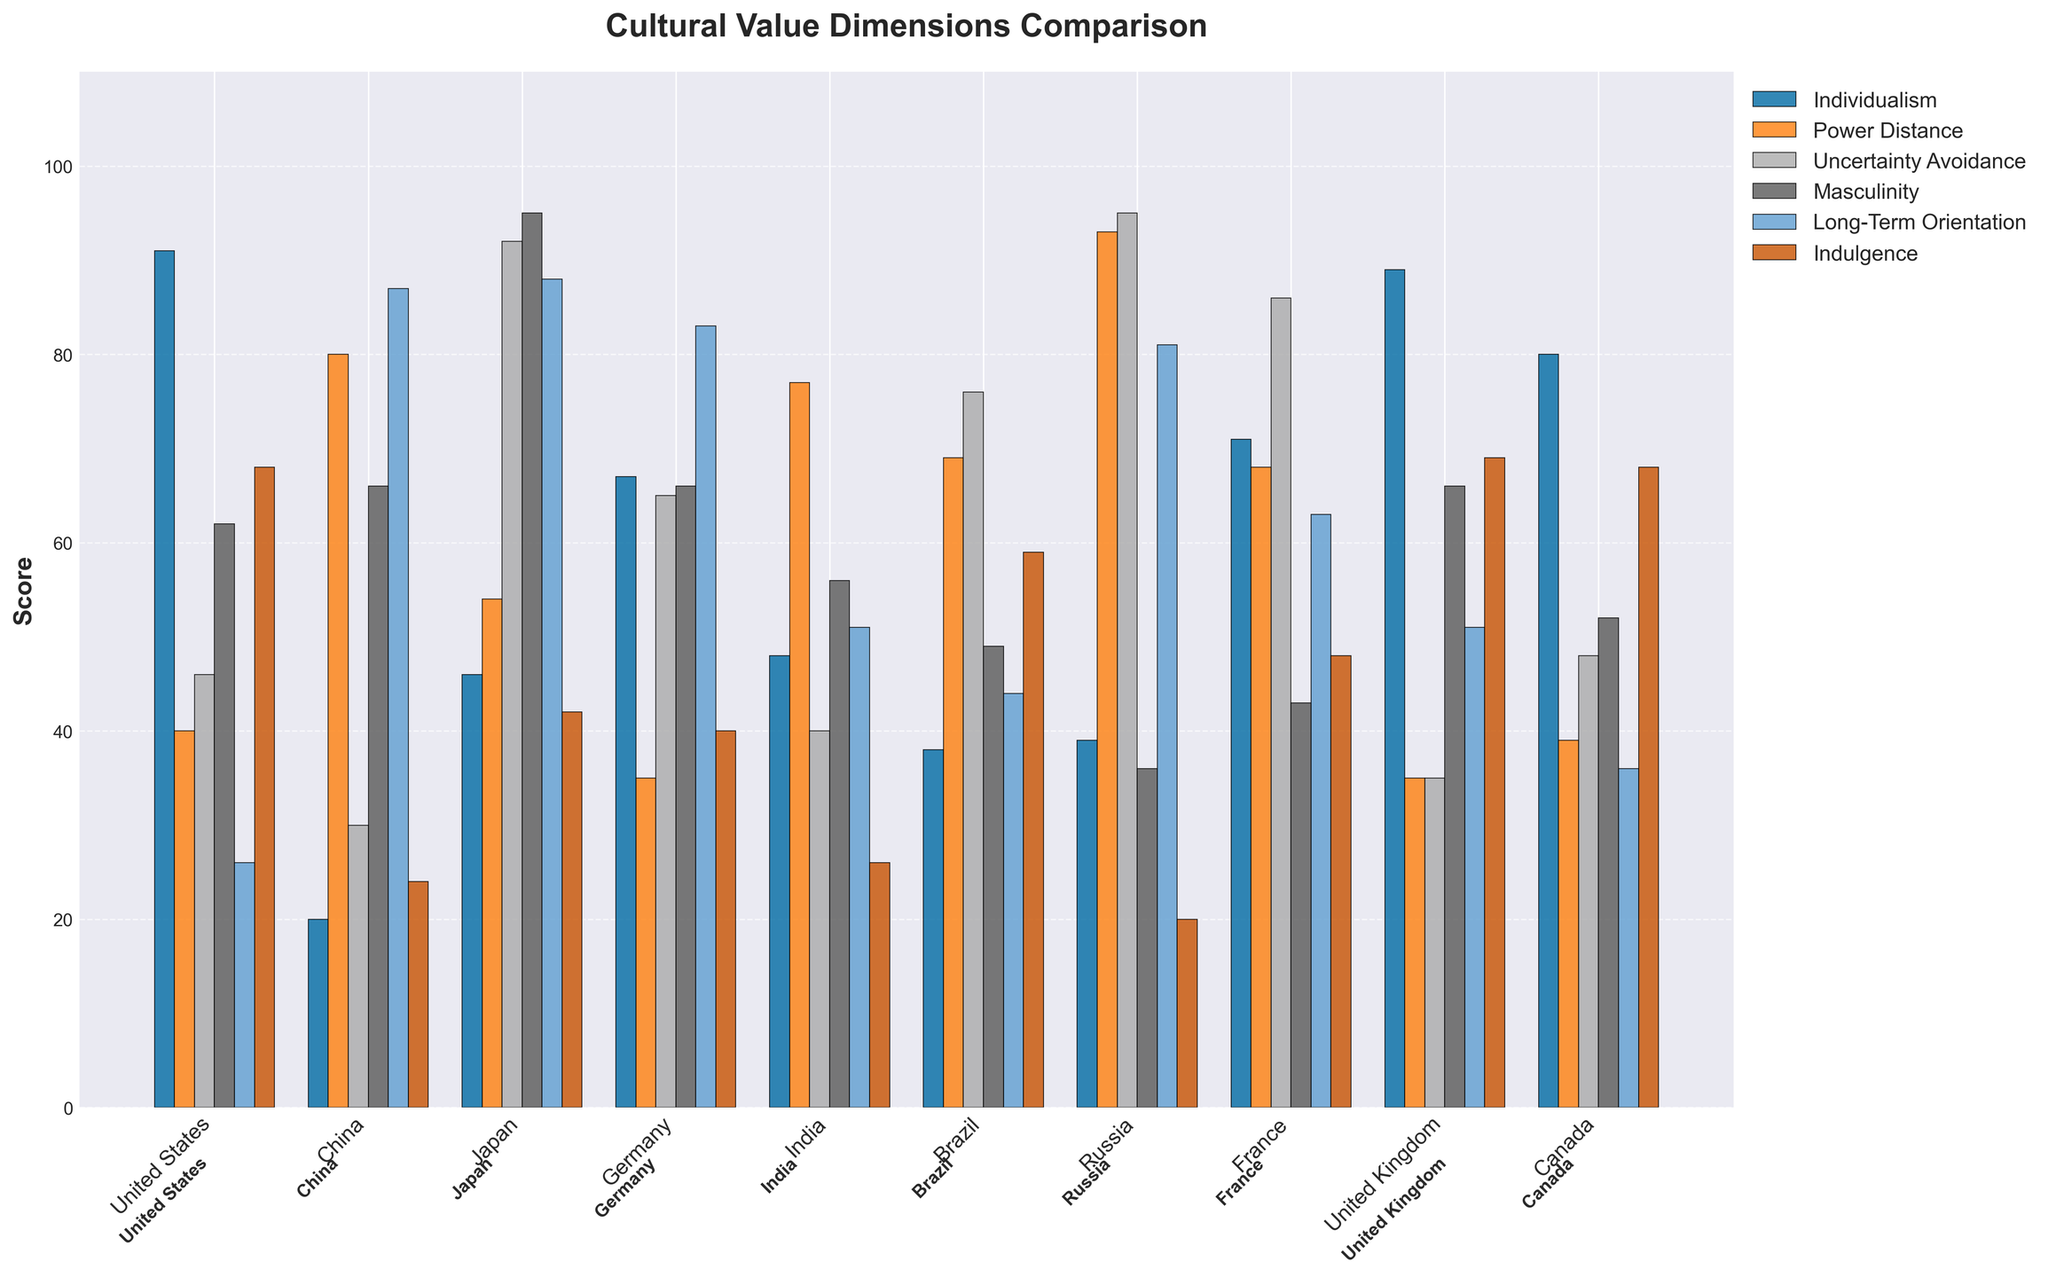Which country has the highest score for Individualism? To find the country with the highest score for Individualism, look for the tallest bar in the 'Individualism' category. The United States has the highest score with a value of 91.
Answer: United States Which country has the lowest score for Power Distance? To identify the country with the lowest score for Power Distance, compare the heights of the bars in the 'Power Distance' category. Sweden has the lowest score with a value of 31.
Answer: Sweden What is the average score for Uncertainty Avoidance among the listed countries? Sum the Uncertainty Avoidance scores for the 10 countries (46 + 30 + 92 + 65 + 40 + 76 + 95 + 86 + 35 + 48) and divide by the number of countries. The total is 613, and the average is 613/10 = 61.3.
Answer: 61.3 How does Germany's score for Masculinity compare to France's score for the same dimension? Look for the bars representing Germany and France in the Masculinity dimension. Germany has a score of 66, while France has a score of 43. Therefore, Germany's score is higher than France's.
Answer: Germany has a higher score Which dimensional score for China is greater: Long-Term Orientation or Masculinity? Compare China's Long-Term Orientation score with its Masculinity score. China has 87 for Long-Term Orientation and 66 for Masculinity, so Long-Term Orientation is greater.
Answer: Long-Term Orientation Among the countries listed, which one has the most balanced scores across all six dimensions? To determine the most balanced scores, observe which country has bars of relatively equal height across all dimensions. For simplicity, look for fewer extremes: the United Kingdom shows relatively balanced scores across all dimensions when comparing individual levels with others.
Answer: United Kingdom What is the total score for Indulgence for the United States, Canada, and Australia combined? Add the Indulgence scores for these three countries: 68 (United States) + 68 (Canada) + 71 (Australia) = 207.
Answer: 207 Which country has a higher combination of Individualism and Power Distance scores: Japan or Brazil? Add the scores for Individualism and Power Distance for both countries. Japan: 46 + 54 = 100. Brazil: 38 + 69 = 107. Therefore, Brazil has a higher combined score.
Answer: Brazil How does the United States' score for Long-Term Orientation compare to South Korea's? Compare the Long-Term Orientation scores for both countries. The United States has a score of 26, and South Korea has a score of 100. Thus, South Korea's score is significantly higher.
Answer: South Korea Which country has the highest combined score of Masculinity and Indulgence? Add the Masculinity and Indulgence scores for the 10 countries and find the highest total. For example: Mexico: 69 (Masculinity) + 97 (Indulgence) = 166. Mexico has the highest combined score.
Answer: Mexico 